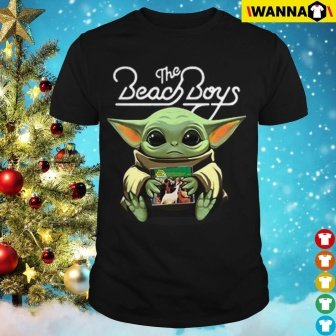Can you explain the significance of the creature on the t-shirt? The creature on the t-shirt is a popular character from a well-known sci-fi series, often associated with themes of wisdom and innocence. By featuring this character holding a potted plant, the t-shirt weaves in symbolism of growth and nurturing, possibly reflecting the nurturing nature of the character itself. This design might resonate with fans of the series, evoking a sense of nostalgia and affection for the character's endearing qualities. 